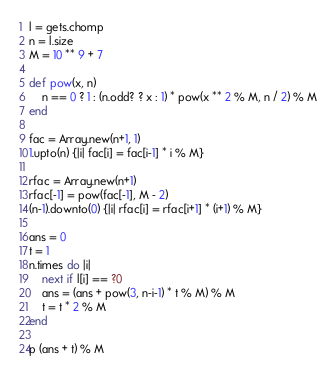Convert code to text. <code><loc_0><loc_0><loc_500><loc_500><_Ruby_>l = gets.chomp
n = l.size
M = 10 ** 9 + 7

def pow(x, n)
    n == 0 ? 1 : (n.odd? ? x : 1) * pow(x ** 2 % M, n / 2) % M
end

fac = Array.new(n+1, 1)
1.upto(n) {|i| fac[i] = fac[i-1] * i % M}

rfac = Array.new(n+1)
rfac[-1] = pow(fac[-1], M - 2)
(n-1).downto(0) {|i| rfac[i] = rfac[i+1] * (i+1) % M}

ans = 0
t = 1
n.times do |i|
    next if l[i] == ?0
    ans = (ans + pow(3, n-i-1) * t % M) % M
    t = t * 2 % M
end

p (ans + t) % M</code> 